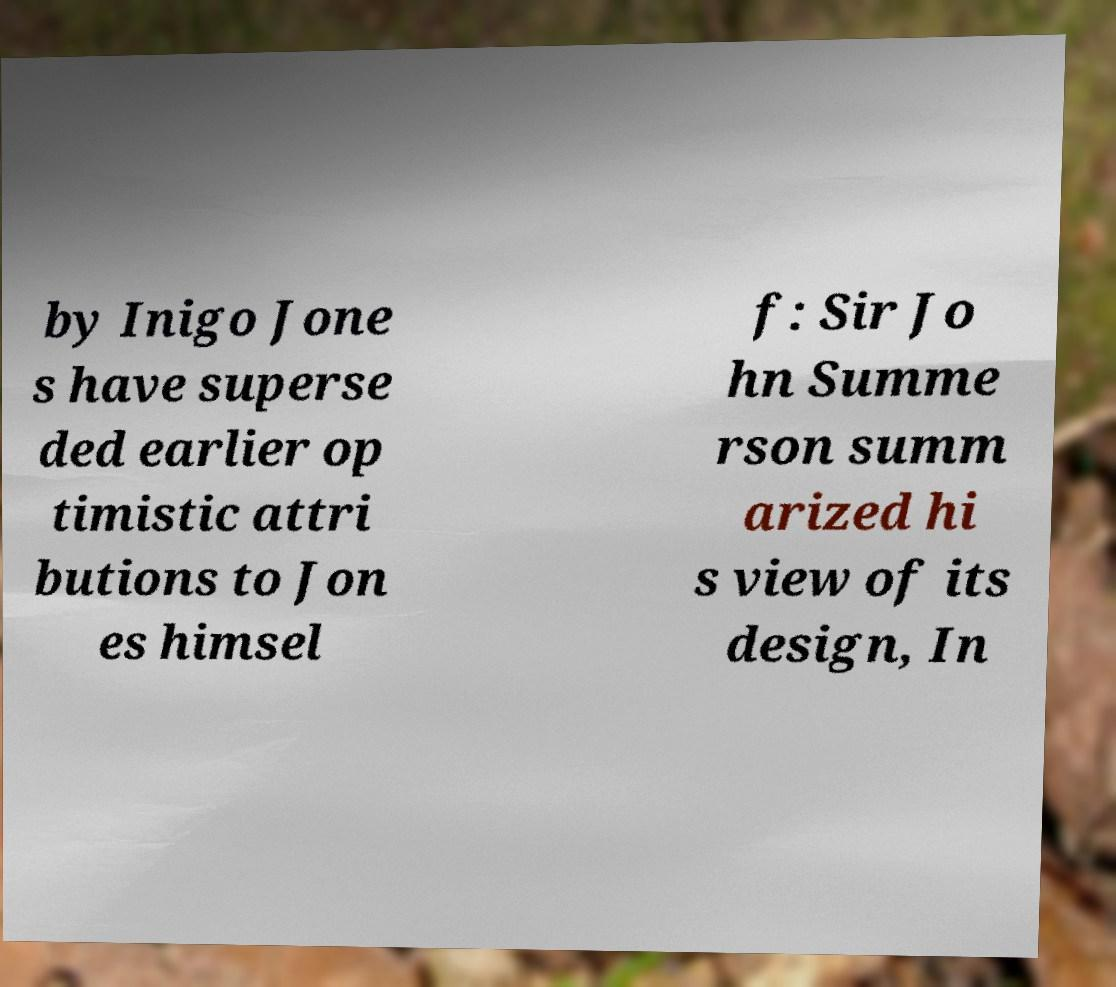Could you extract and type out the text from this image? by Inigo Jone s have superse ded earlier op timistic attri butions to Jon es himsel f: Sir Jo hn Summe rson summ arized hi s view of its design, In 